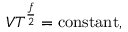<formula> <loc_0><loc_0><loc_500><loc_500>V T ^ { \frac { f } { 2 } } = { c o n s t a n t } ,</formula> 